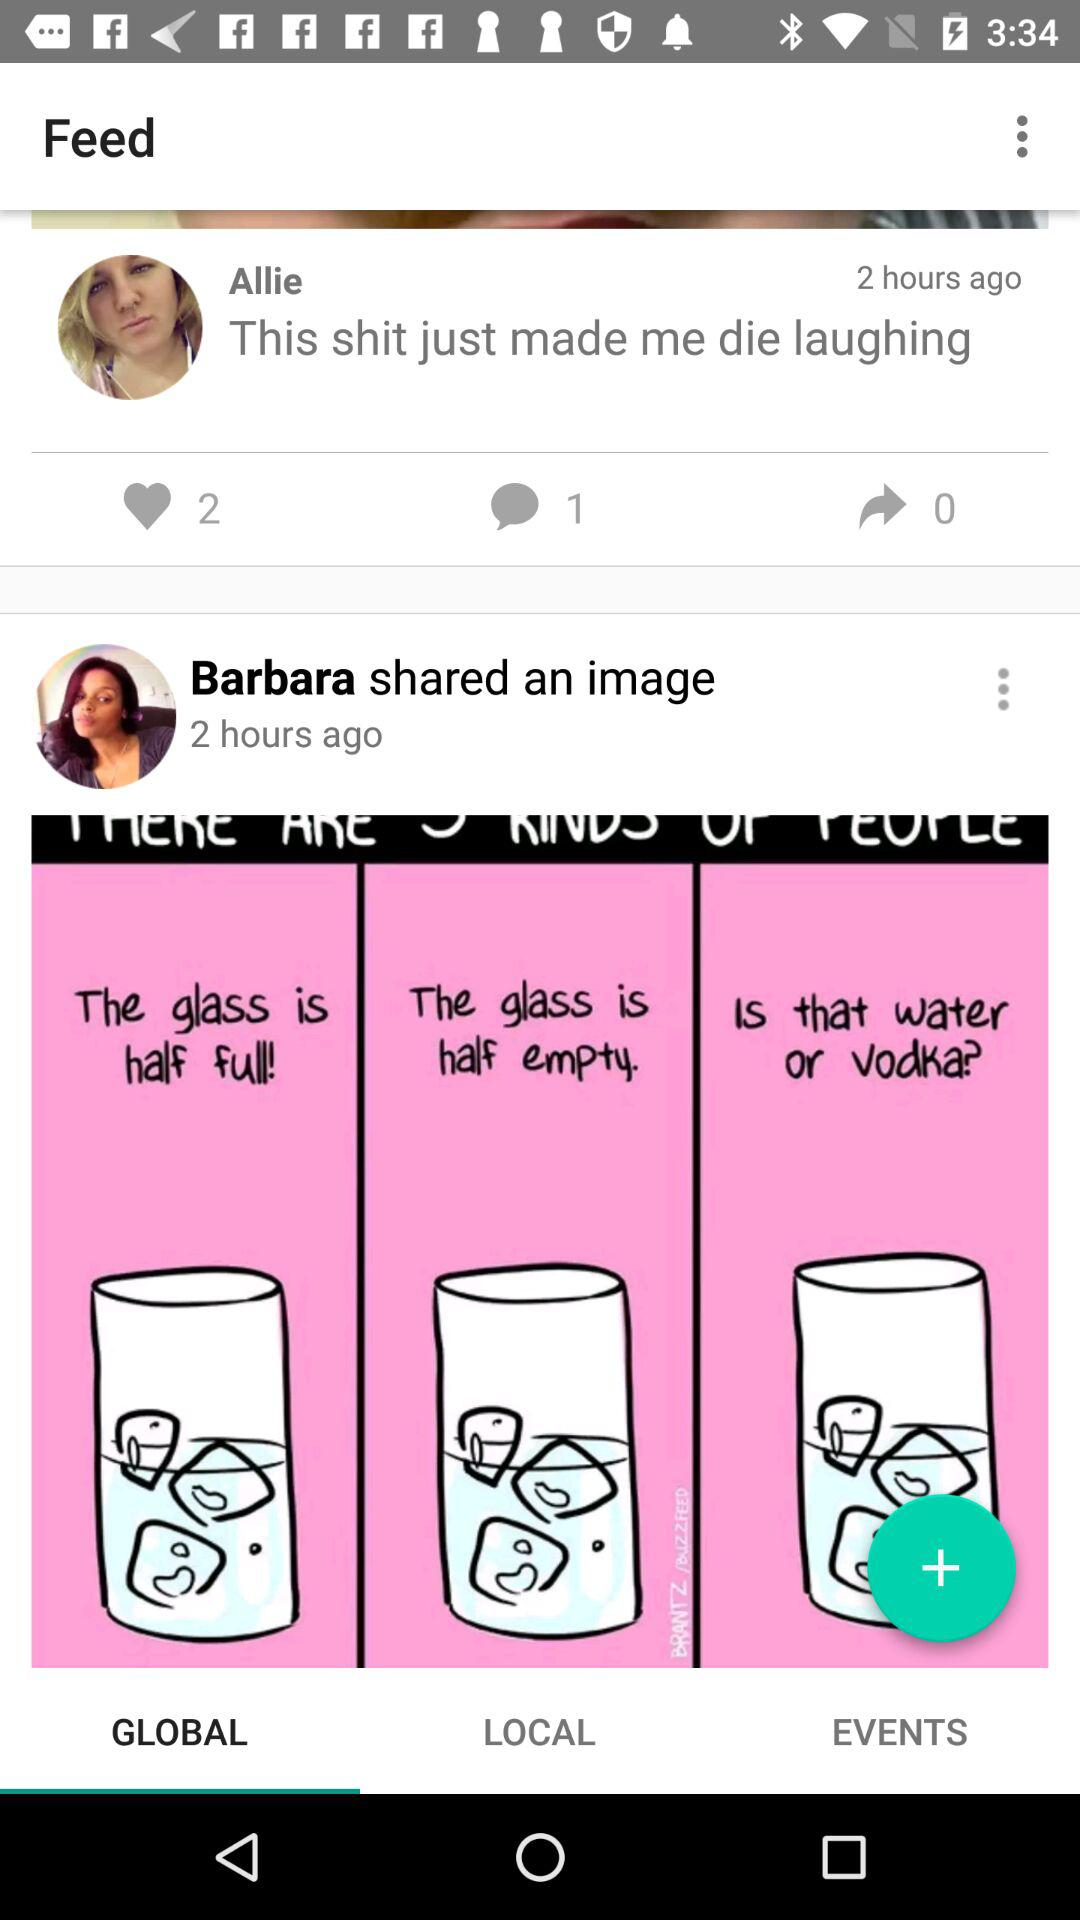When did Allie post the statement? Allie posted the statement two hours ago. 